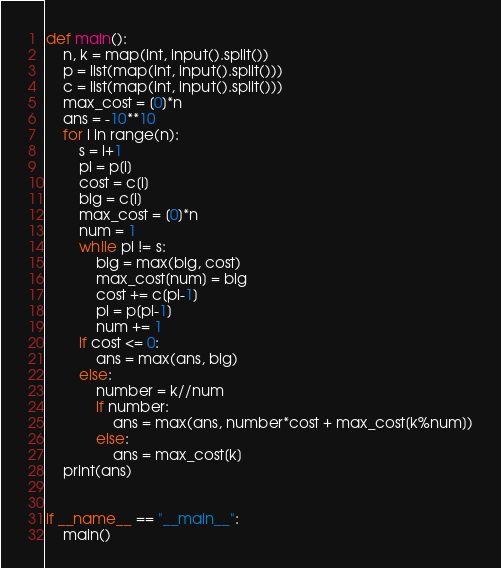Convert code to text. <code><loc_0><loc_0><loc_500><loc_500><_Python_>def main():
    n, k = map(int, input().split())
    p = list(map(int, input().split()))
    c = list(map(int, input().split()))
    max_cost = [0]*n
    ans = -10**10
    for i in range(n):
        s = i+1
        pi = p[i]
        cost = c[i]
        big = c[i]
        max_cost = [0]*n
        num = 1
        while pi != s:
            big = max(big, cost)
            max_cost[num] = big
            cost += c[pi-1]
            pi = p[pi-1]
            num += 1
        if cost <= 0:
            ans = max(ans, big)
        else:
            number = k//num
            if number:
                ans = max(ans, number*cost + max_cost[k%num])
            else:
                ans = max_cost[k]
    print(ans)
            

if __name__ == "__main__":
    main()</code> 